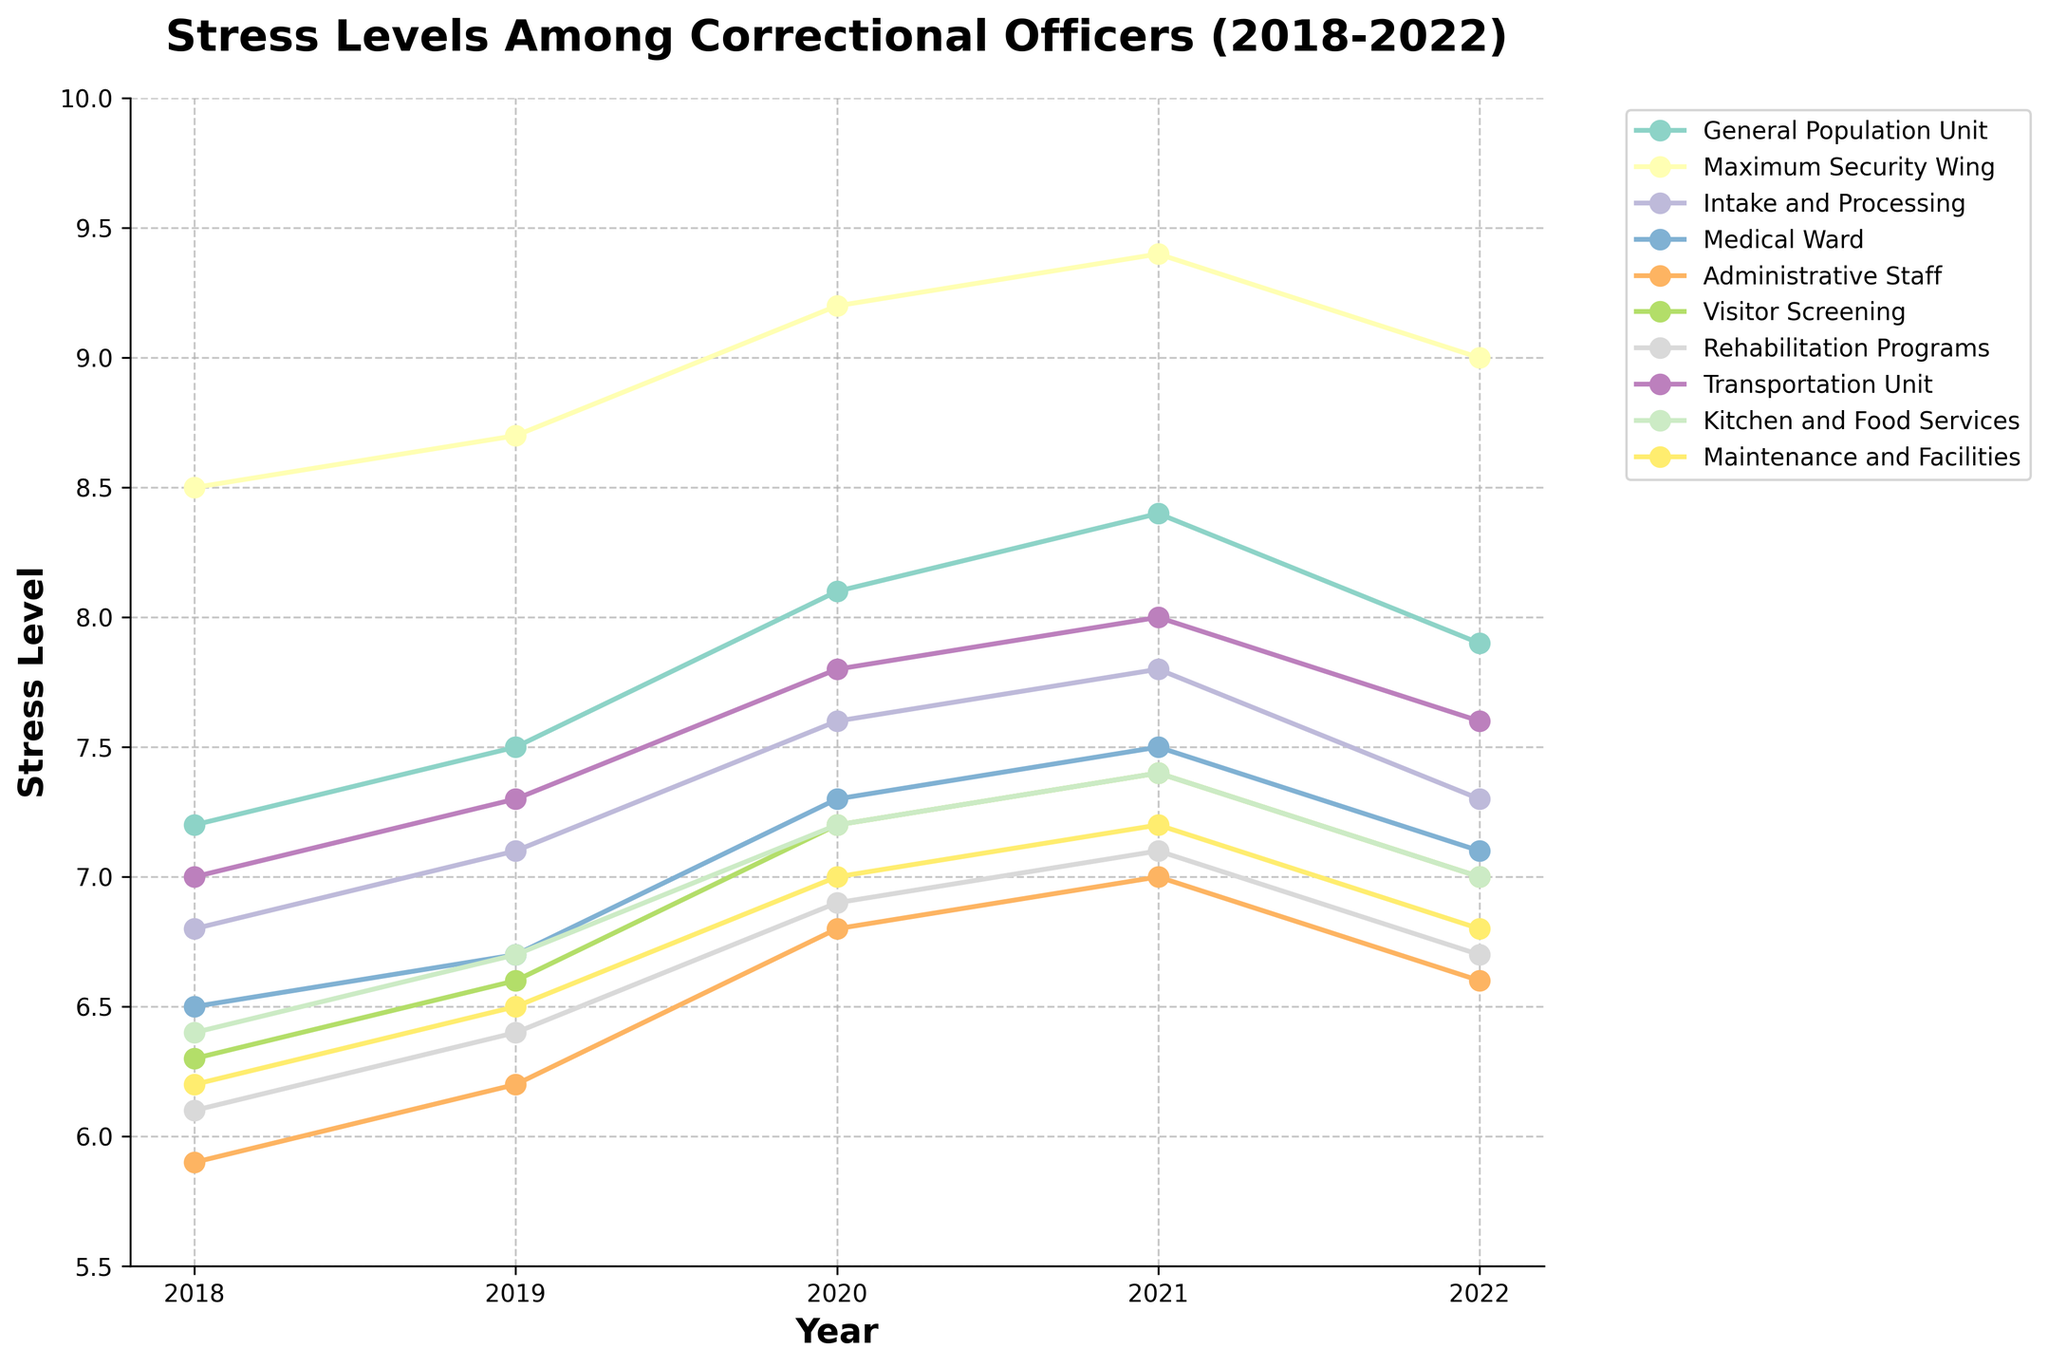What is the trend in stress levels for the General Population Unit over the 5 years? Look at the line representing the General Population Unit. From 2018 to 2022, the stress levels increased from 7.2 in 2018 to 7.9 in 2022, peaking at 8.4 in 2021 before slightly declining in 2022.
Answer: Increasing trend with a peak in 2021 Which department experienced the highest stress level in any year, and what was that level? Look for the highest point on the y-axis across all departments. The Maximum Security Wing had the highest stress level, reaching 9.4 in 2021.
Answer: Maximum Security Wing, 9.4 How did the stress levels of Administrative Staff change from 2020 to 2022? Observe the point for Administrative Staff in 2020 (6.8), 2021 (7.0), and 2022 (6.6). The stress level increased from 6.8 to 7.0 and then decreased to 6.6.
Answer: Increased and then decreased What is the difference in stress levels between Intake and Processing and Kitchen and Food Services in 2022? Find the stress levels for both departments in 2022. For Intake and Processing, it is 7.3, and for Kitchen and Food Services, it is 7.0. The difference is 7.3 - 7.0 = 0.3.
Answer: 0.3 Which department had the lowest stress level in 2020 and what was the value? Look for the lowest point on the y-axis in 2020. The Medical Ward had the lowest stress level with a value of 7.3.
Answer: Medical Ward, 7.3 Compare the trend of stress levels in the Maximum Security Wing and Visitor Screening between 2018 and 2022. Both departments had an increasing trend from 2018 to 2022. The Maximum Security Wing increased from 8.5 to 9.0, peaking at 9.4 in 2021. Visitor Screening increased from 6.3 to 7.0, peaking at 7.4 in 2021.
Answer: Increasing trend for both What is the average stress level for the Transportation Unit over the five years? Sum the values from 2018 to 2022 (7.0 + 7.3 + 7.8 + 8.0 + 7.6) = 37.7; divide by the number of years, 37.7 / 5 = 7.54.
Answer: 7.54 Which department showed a decrease in stress level from 2021 to 2022? Compare the values in 2021 and 2022 for each department. The General Population Unit, Maximum Security Wing, Intake and Processing, Medical Ward, Administrative Staff, Visitor Screening, Rehabilitation Programs, and Kitchen and Food Services all showed decreases.
Answer: Several departments showed a decrease What was the median stress level across all departments in 2020? List the 2020 stress levels: 6.8, 6.9, 7.0, 7.2, 7.2, 7.3, 7.3, 7.6, 7.8, 9.2. The median is the middle value in the sorted list, so (7.2 + 7.3)/2 = 7.25.
Answer: 7.25 Between which years did the Rehabilitation Programs department see the highest increase in stress level? Compare the differences between consecutive years for Rehabilitation Programs: 6.1 to 6.4 (0.3), 6.4 to 6.9 (0.5), 6.9 to 7.1 (0.2), and 7.1 to 6.7 (-0.4). The highest increase was between 2019 and 2020.
Answer: 2019 to 2020 